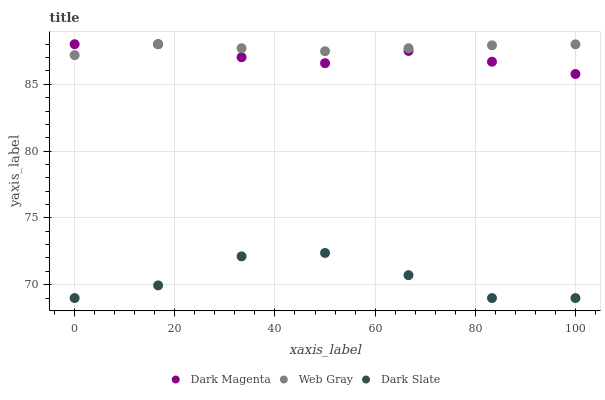Does Dark Slate have the minimum area under the curve?
Answer yes or no. Yes. Does Web Gray have the maximum area under the curve?
Answer yes or no. Yes. Does Dark Magenta have the minimum area under the curve?
Answer yes or no. No. Does Dark Magenta have the maximum area under the curve?
Answer yes or no. No. Is Web Gray the smoothest?
Answer yes or no. Yes. Is Dark Slate the roughest?
Answer yes or no. Yes. Is Dark Magenta the smoothest?
Answer yes or no. No. Is Dark Magenta the roughest?
Answer yes or no. No. Does Dark Slate have the lowest value?
Answer yes or no. Yes. Does Dark Magenta have the lowest value?
Answer yes or no. No. Does Dark Magenta have the highest value?
Answer yes or no. Yes. Is Dark Slate less than Dark Magenta?
Answer yes or no. Yes. Is Dark Magenta greater than Dark Slate?
Answer yes or no. Yes. Does Web Gray intersect Dark Magenta?
Answer yes or no. Yes. Is Web Gray less than Dark Magenta?
Answer yes or no. No. Is Web Gray greater than Dark Magenta?
Answer yes or no. No. Does Dark Slate intersect Dark Magenta?
Answer yes or no. No. 